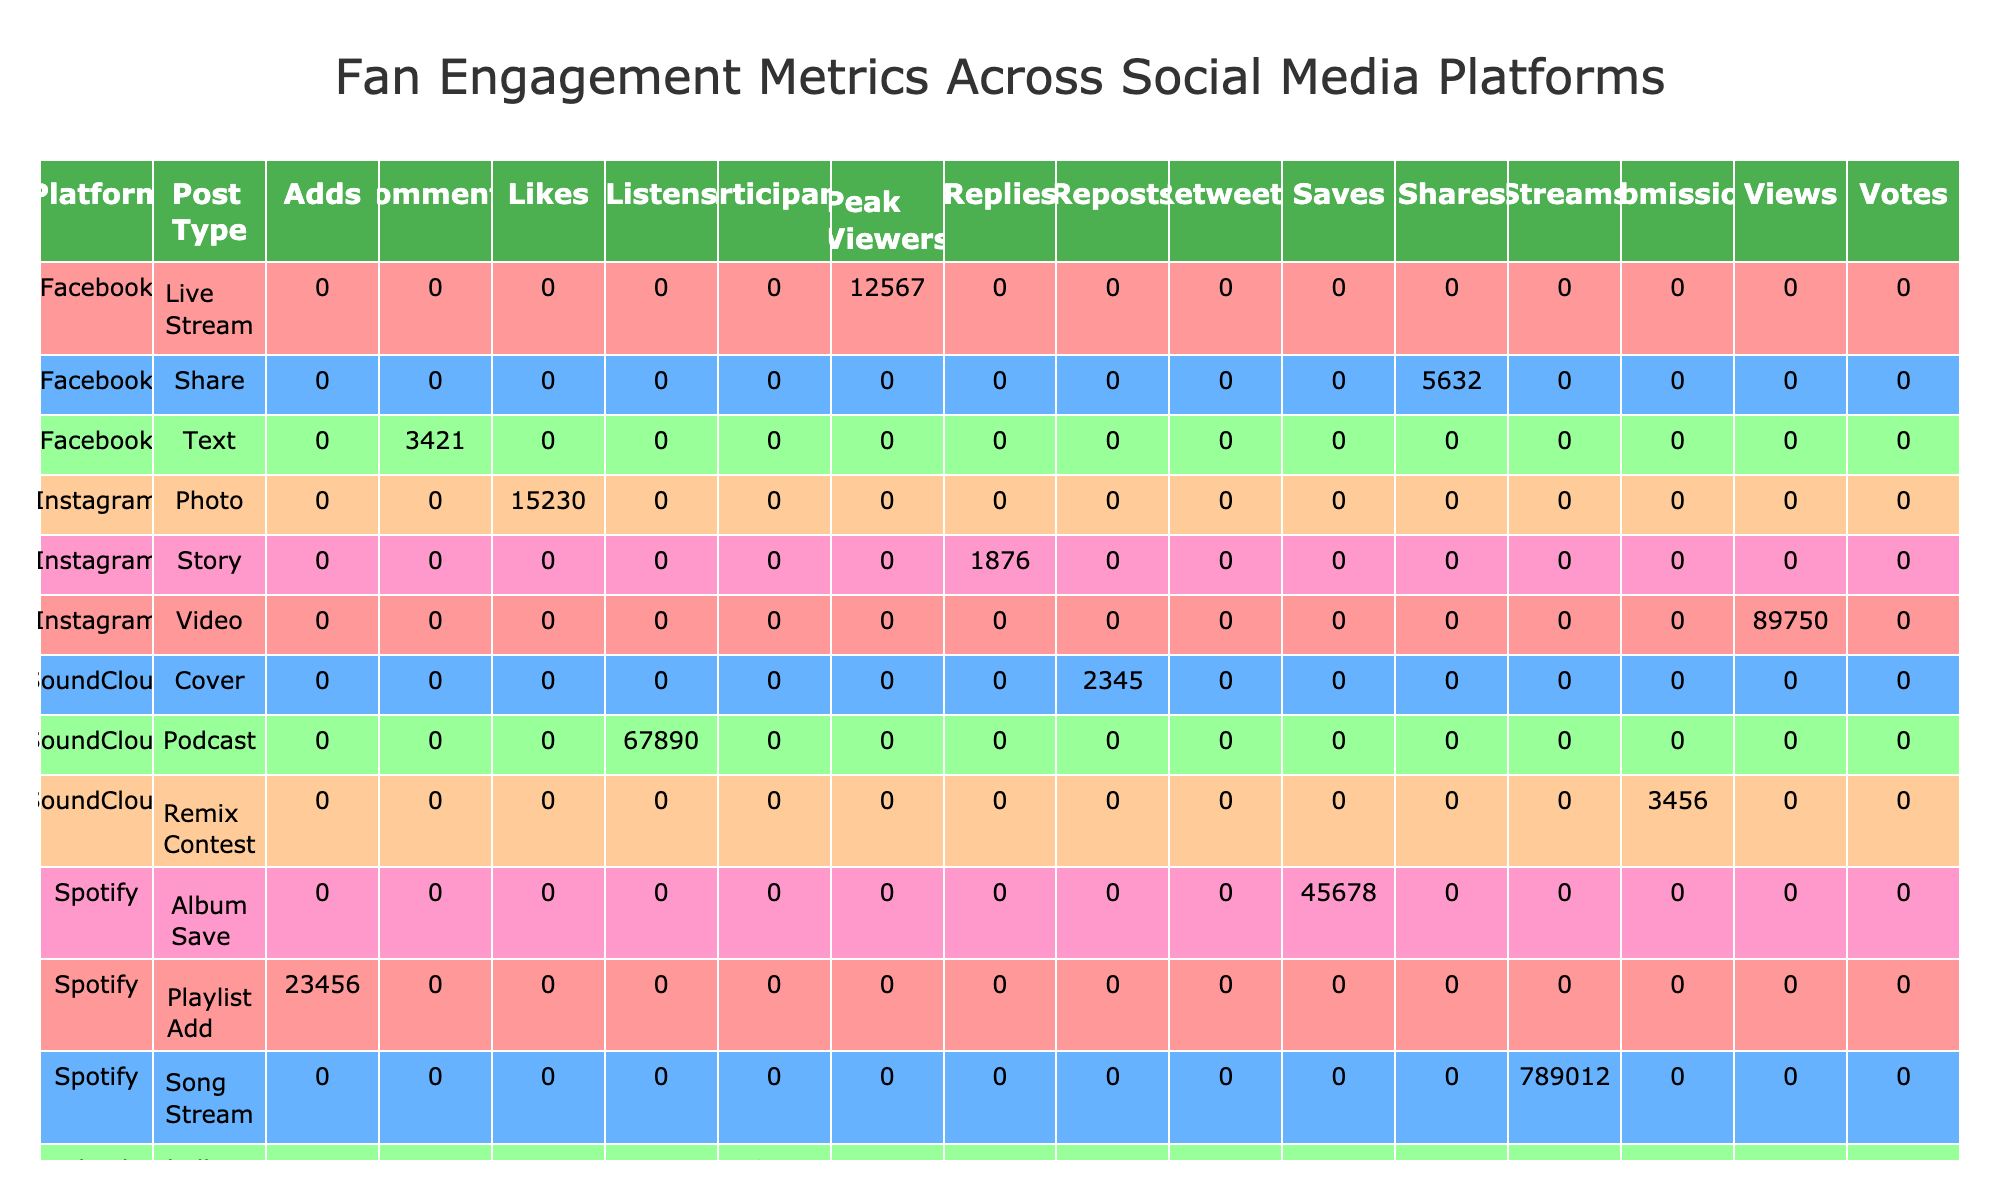What platform had the highest total engagement for Likes? To find the platform with the highest total engagement for Likes, we look specifically under the Likes category for each platform. Instagram has 15,230 Likes, YouTube has 34,567 Likes, and SoundCloud has no Likes listed. Therefore, YouTube leads with 34,567 Likes.
Answer: YouTube How many total Views did TikTok generate across all Post Types? We sum the Views under TikTok's post types: TikTok Challenge has 98,765 Views, and TikTok Duet has 456,789 Views. Adding these gives us 98,765 + 456,789 = 555,554 Views total.
Answer: 555,554 Did Facebook have more Shares or Comments? Under Facebook, there are 3,421 Comments and 5,632 Shares. Since 5,632 is greater than 3,421, Facebook had more Shares than Comments.
Answer: Yes What was the total engagement in Streams for Spotify? With only one engagement type recorded under Spotify for Streams, we refer to that value, which is 789,012. Since there are no other types included for Spotify engagement totals in the context of Streams, the answer remains the same.
Answer: 789,012 Which Post Type on Instagram received the least engagement? Reviewing the engagement types listed for Instagram: Likes (15,230), Views (89,750), and Replies (1,876) indicates that Replies received the least engagement, as 1,876 is less than the others.
Answer: Story What was the cumulative number of Likes across all platforms that showed Likes as an engagement type? We gather Likes from all platforms: Instagram has 15,230 Likes, YouTube has 34,567 Likes, and SoundCloud has no Likes, totaling 15,230 + 34,567 = 49,797 Likes overall.
Answer: 49,797 Is there a platform where the Engagement Type "Submissions" was recorded? Checking the data, Submissions is present under SoundCloud's Remix Contest. Therefore, there is indeed a platform with that engagement type.
Answer: Yes How does the total number of Views on YouTube compare to the total number of Votes on Twitter? The total Views on YouTube is 567,890, and the Votes on Twitter total 6,789. Comparing these numbers shows that 567,890 is significantly higher than 6,789, indicating more engagement overall on YouTube.
Answer: More 